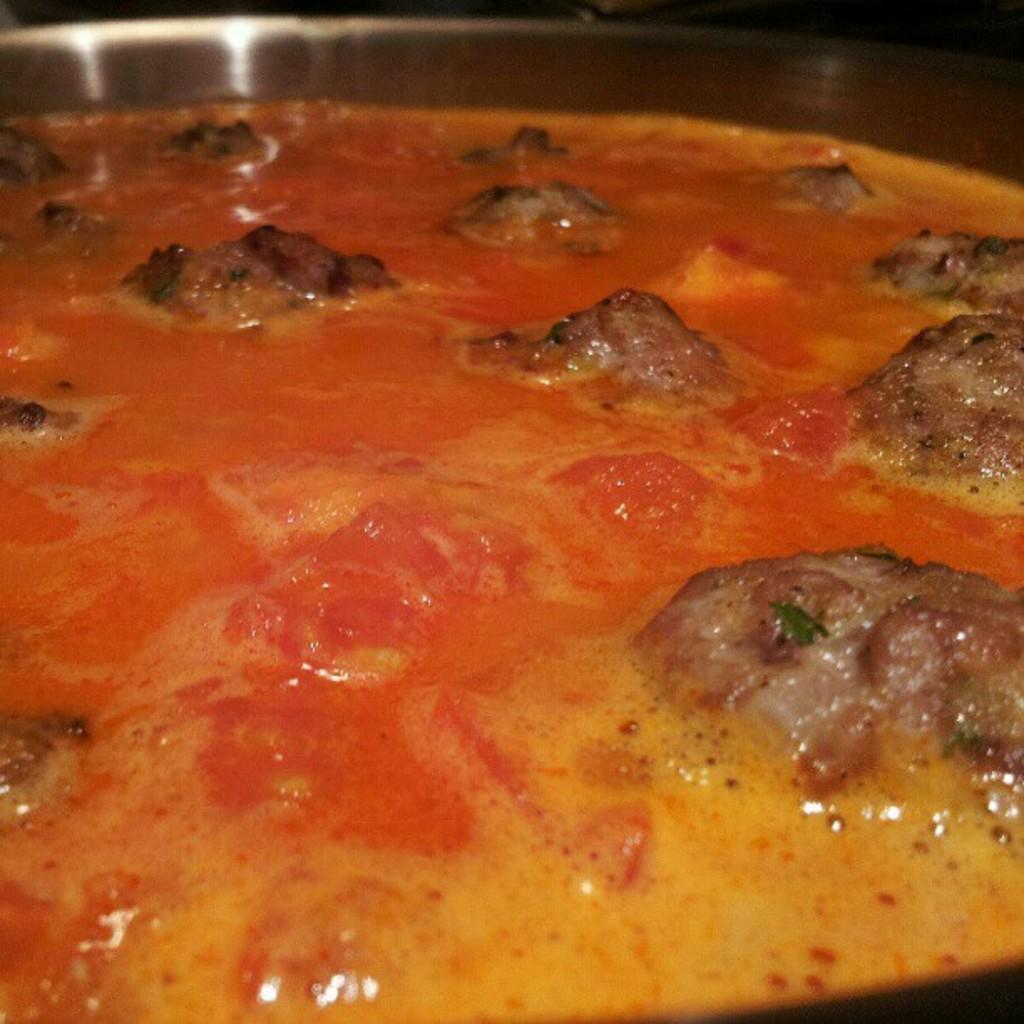How would you summarize this image in a sentence or two? In this image I can see the food which is in yellow, brown and red color. It is in the brown color bowl. And there is a black background. 